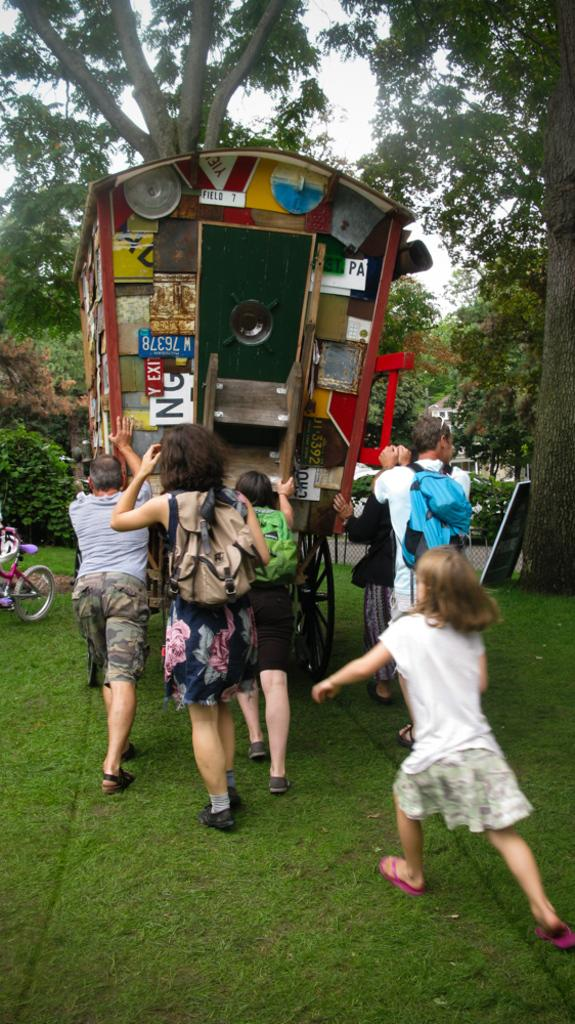What are the people in the image doing? The people in the image are pushing a vehicle. What type of natural elements can be seen in the image? There are plants, trees, and grass visible in the image. What mode of transportation is present in the image? There is a bicycle in the image. What is visible in the background of the image? There is a sky visible in the image. Can you see a robin in the image? No, there is no robin visible in the image. Is there an army present in the image? No, there is no army present in the image. Can you see a secretary in the image? No, there is no secretary present in the image. 